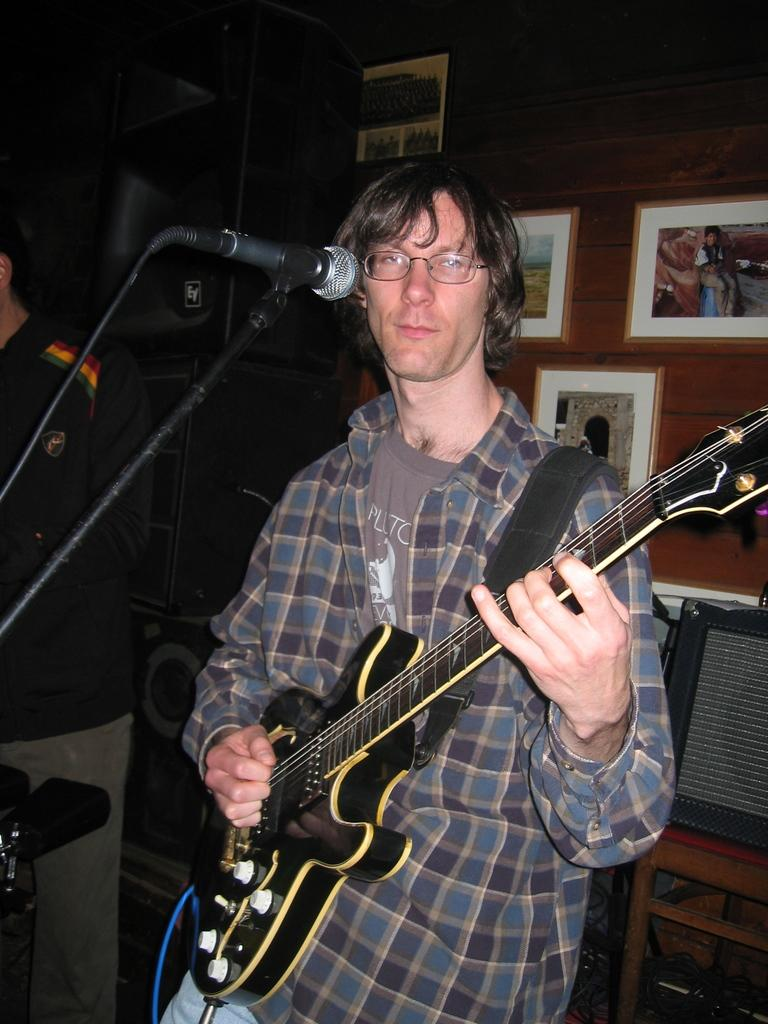Who is present in the image? There is a man in the image. What is the man holding in his hand? The man is holding a guitar in his hand. How many heads does the guitar have in the image? The guitar does not have a head in the image, as it is an inanimate object and does not possess human features. 